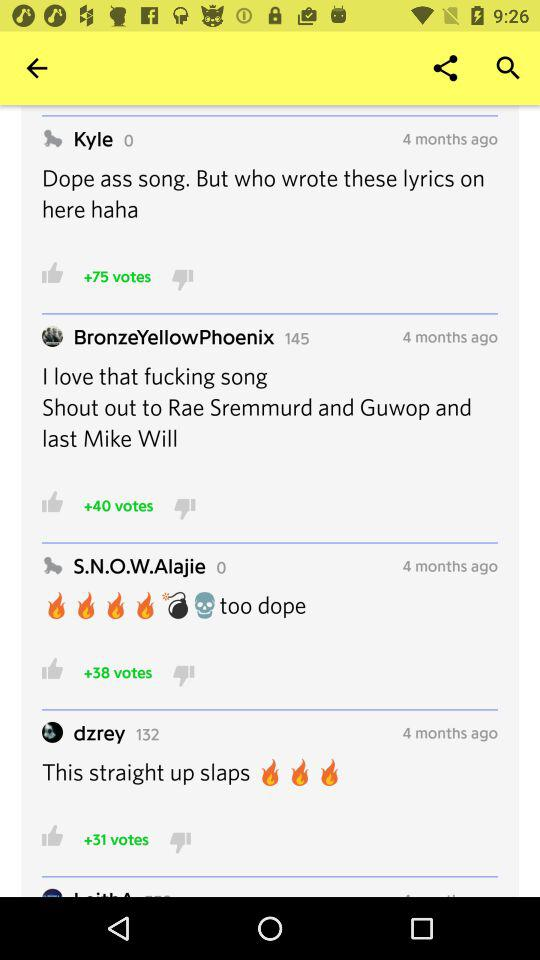How many votes are given to "dzrey" comment? There are 31 votes given to "dzrey" comment. 